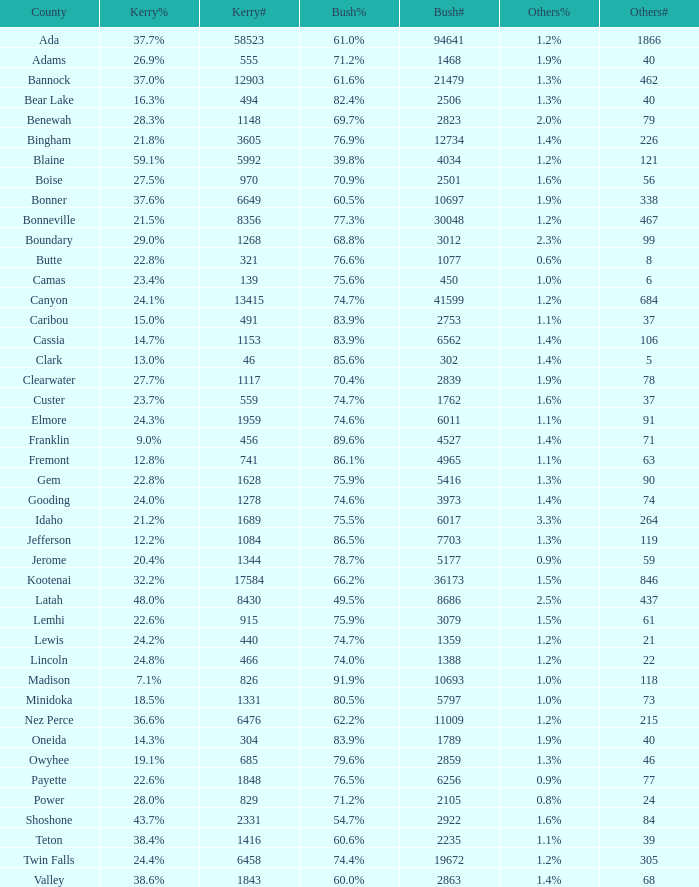In the county where 462 individuals cast their votes for others, what was the proportion of such votes in terms of percentage? 1.3%. 